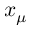<formula> <loc_0><loc_0><loc_500><loc_500>x _ { \mu }</formula> 